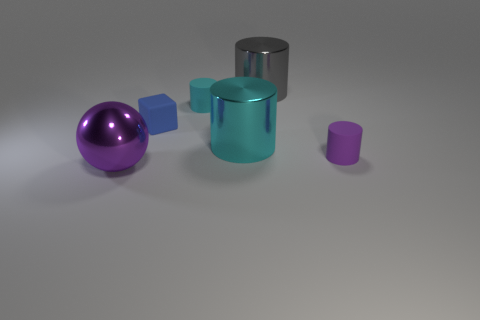Add 3 big yellow metallic cylinders. How many objects exist? 9 Subtract all cubes. How many objects are left? 5 Subtract all purple cylinders. Subtract all big cyan shiny objects. How many objects are left? 4 Add 6 tiny cyan cylinders. How many tiny cyan cylinders are left? 7 Add 1 purple shiny things. How many purple shiny things exist? 2 Subtract 0 red spheres. How many objects are left? 6 